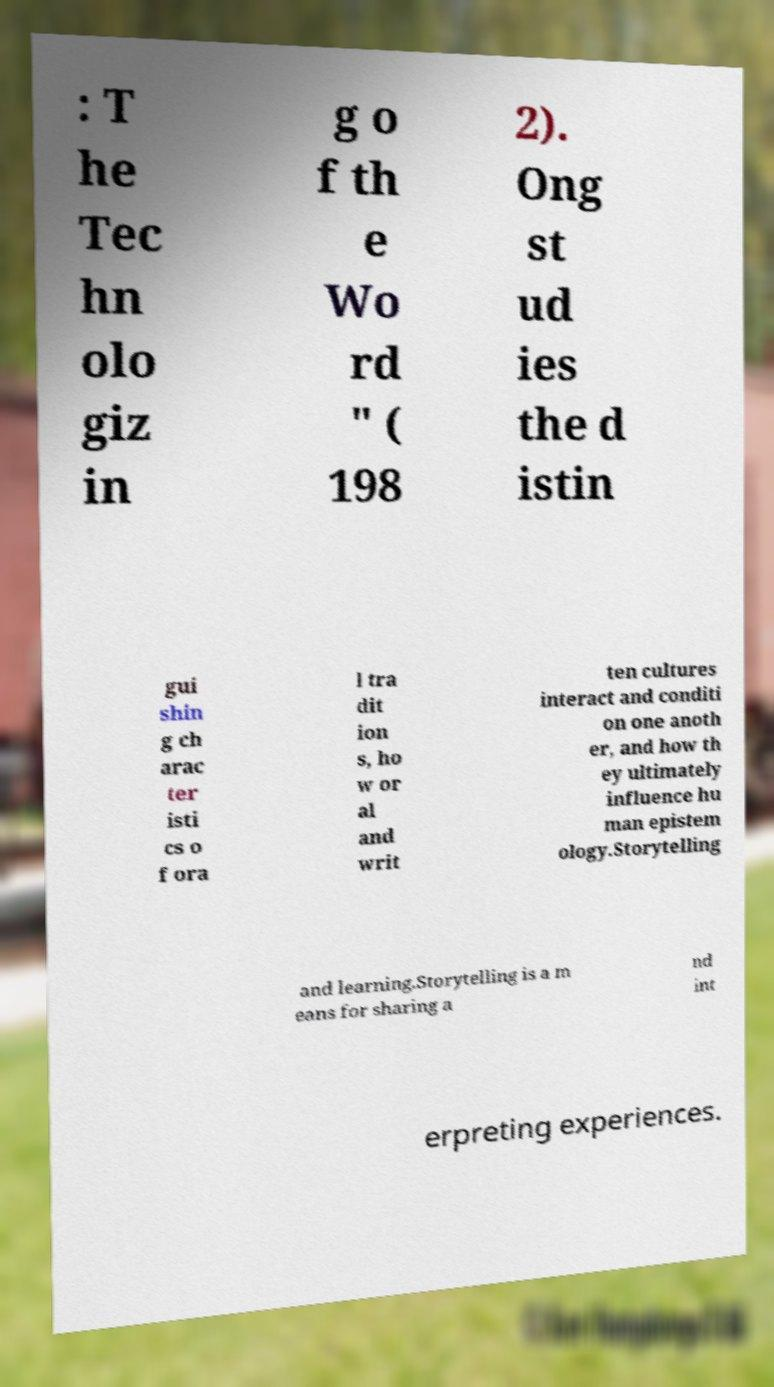There's text embedded in this image that I need extracted. Can you transcribe it verbatim? : T he Tec hn olo giz in g o f th e Wo rd " ( 198 2). Ong st ud ies the d istin gui shin g ch arac ter isti cs o f ora l tra dit ion s, ho w or al and writ ten cultures interact and conditi on one anoth er, and how th ey ultimately influence hu man epistem ology.Storytelling and learning.Storytelling is a m eans for sharing a nd int erpreting experiences. 